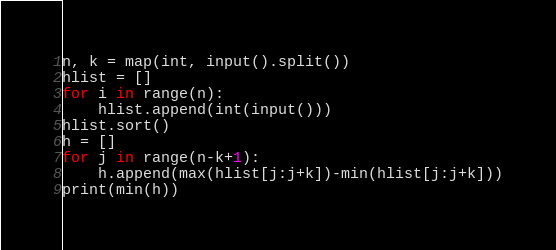<code> <loc_0><loc_0><loc_500><loc_500><_Python_>n, k = map(int, input().split())
hlist = []
for i in range(n):
    hlist.append(int(input()))
hlist.sort()
h = []
for j in range(n-k+1):
    h.append(max(hlist[j:j+k])-min(hlist[j:j+k]))
print(min(h))
</code> 